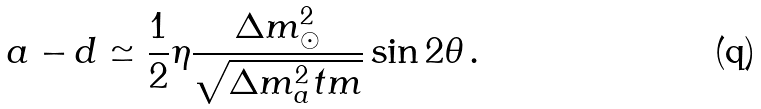Convert formula to latex. <formula><loc_0><loc_0><loc_500><loc_500>a - d \simeq \frac { 1 } { 2 } \eta \frac { \Delta m ^ { 2 } _ { \odot } } { \sqrt { \Delta m ^ { 2 } _ { a } t m } } \sin 2 \theta \, .</formula> 